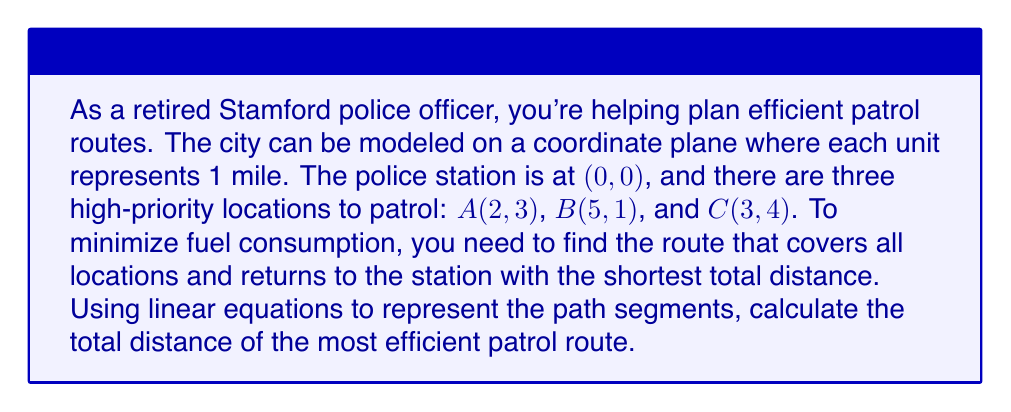Can you answer this question? Let's approach this step-by-step:

1) First, we need to calculate the distances between all points:
   Station to A: $\sqrt{2^2 + 3^2} = \sqrt{13}$
   Station to B: $\sqrt{5^2 + 1^2} = \sqrt{26}$
   Station to C: $\sqrt{3^2 + 4^2} = 5$
   A to B: $\sqrt{3^2 + (-2)^2} = \sqrt{13}$
   A to C: $\sqrt{1^2 + 1^2} = \sqrt{2}$
   B to C: $\sqrt{(-2)^2 + 3^2} = \sqrt{13}$

2) The most efficient route will visit all points once and return to the station. There are six possible routes:
   Station -> A -> B -> C -> Station
   Station -> A -> C -> B -> Station
   Station -> B -> A -> C -> Station
   Station -> B -> C -> A -> Station
   Station -> C -> A -> B -> Station
   Station -> C -> B -> A -> Station

3) Let's calculate the total distance for each route:
   S-A-B-C-S: $\sqrt{13} + \sqrt{13} + \sqrt{13} + 5 = 2\sqrt{13} + 5 + \sqrt{13}$
   S-A-C-B-S: $\sqrt{13} + \sqrt{2} + \sqrt{13} + \sqrt{26} = \sqrt{26} + \sqrt{2} + 2\sqrt{13}$
   S-B-A-C-S: $\sqrt{26} + \sqrt{13} + \sqrt{2} + 5 = 5 + \sqrt{2} + \sqrt{13} + \sqrt{26}$
   S-B-C-A-S: $\sqrt{26} + \sqrt{13} + \sqrt{2} + \sqrt{13} = \sqrt{2} + 2\sqrt{13} + \sqrt{26}$
   S-C-A-B-S: $5 + \sqrt{2} + \sqrt{13} + \sqrt{26} = 5 + \sqrt{2} + \sqrt{13} + \sqrt{26}$
   S-C-B-A-S: $5 + \sqrt{13} + \sqrt{13} + \sqrt{13} = 5 + 3\sqrt{13}$

4) The shortest route is S-A-B-C-S with a total distance of $2\sqrt{13} + 5 + \sqrt{13} = 3\sqrt{13} + 5$ miles.

5) To represent this route with linear equations:
   S to A: $y = \frac{3}{2}x$ for $0 \leq x \leq 2$
   A to B: $y = -\frac{2}{3}x + 5$ for $2 \leq x \leq 5$
   B to C: $y = x - 1$ for $3 \leq x \leq 5$
   C to S: $y = -\frac{4}{3}x + 4$ for $0 \leq x \leq 3$
Answer: $3\sqrt{13} + 5$ miles 